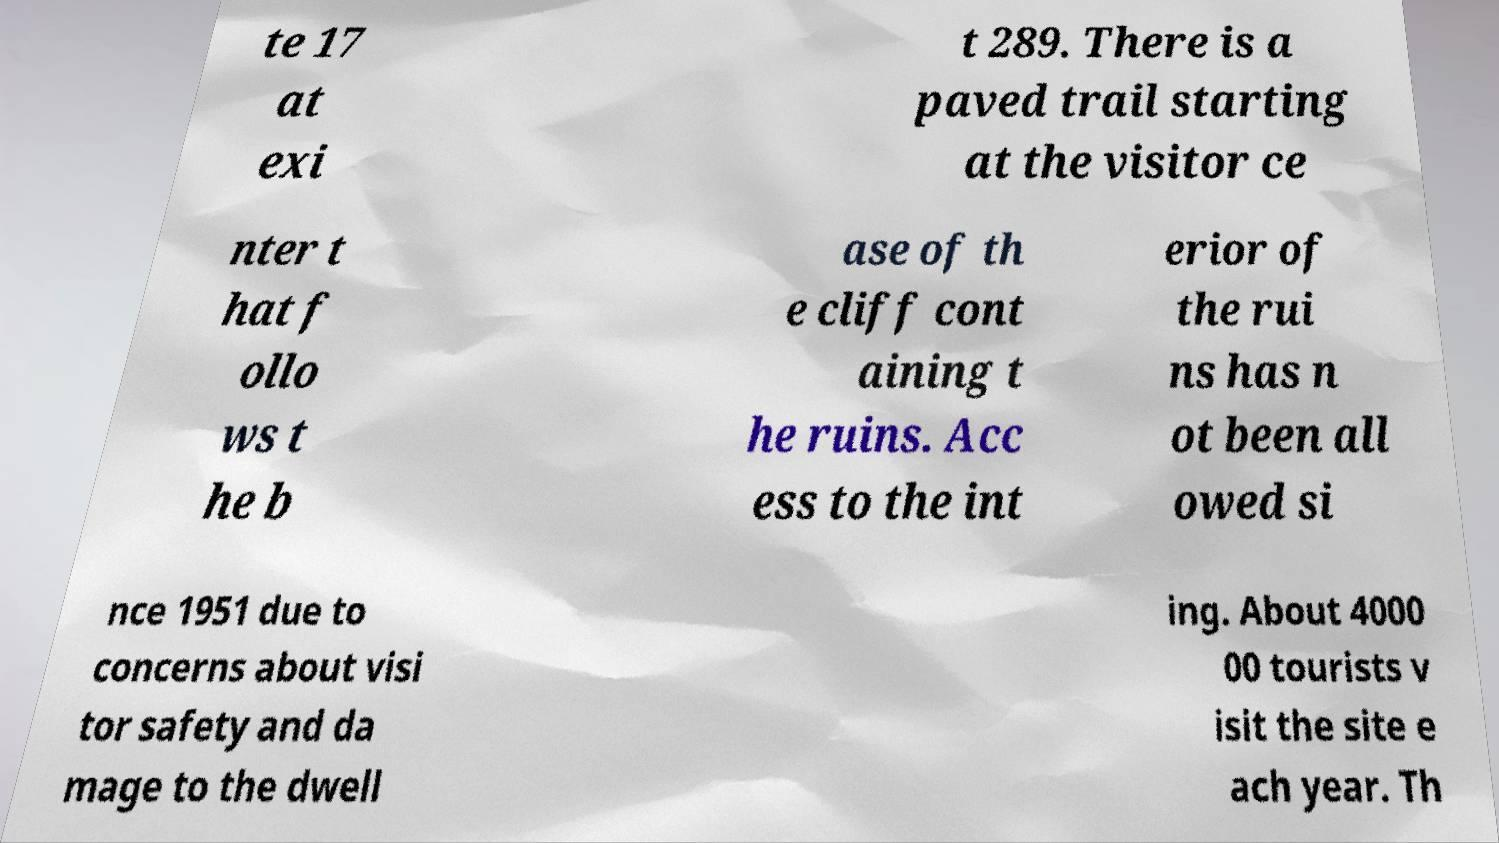Could you assist in decoding the text presented in this image and type it out clearly? te 17 at exi t 289. There is a paved trail starting at the visitor ce nter t hat f ollo ws t he b ase of th e cliff cont aining t he ruins. Acc ess to the int erior of the rui ns has n ot been all owed si nce 1951 due to concerns about visi tor safety and da mage to the dwell ing. About 4000 00 tourists v isit the site e ach year. Th 